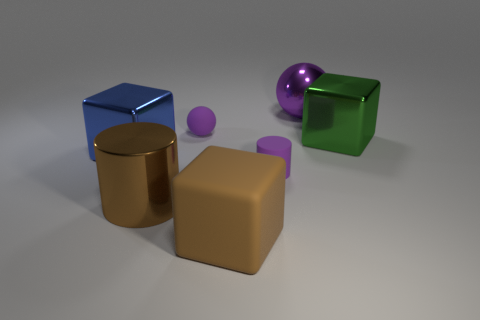Add 3 purple metallic spheres. How many objects exist? 10 Subtract all cylinders. How many objects are left? 5 Subtract all purple matte balls. Subtract all big brown rubber cubes. How many objects are left? 5 Add 6 purple spheres. How many purple spheres are left? 8 Add 2 metallic things. How many metallic things exist? 6 Subtract 0 blue cylinders. How many objects are left? 7 